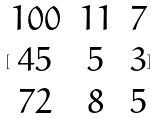<formula> <loc_0><loc_0><loc_500><loc_500>[ \begin{matrix} 1 0 0 & 1 1 & 7 \\ 4 5 & 5 & 3 \\ 7 2 & 8 & 5 \end{matrix} ]</formula> 